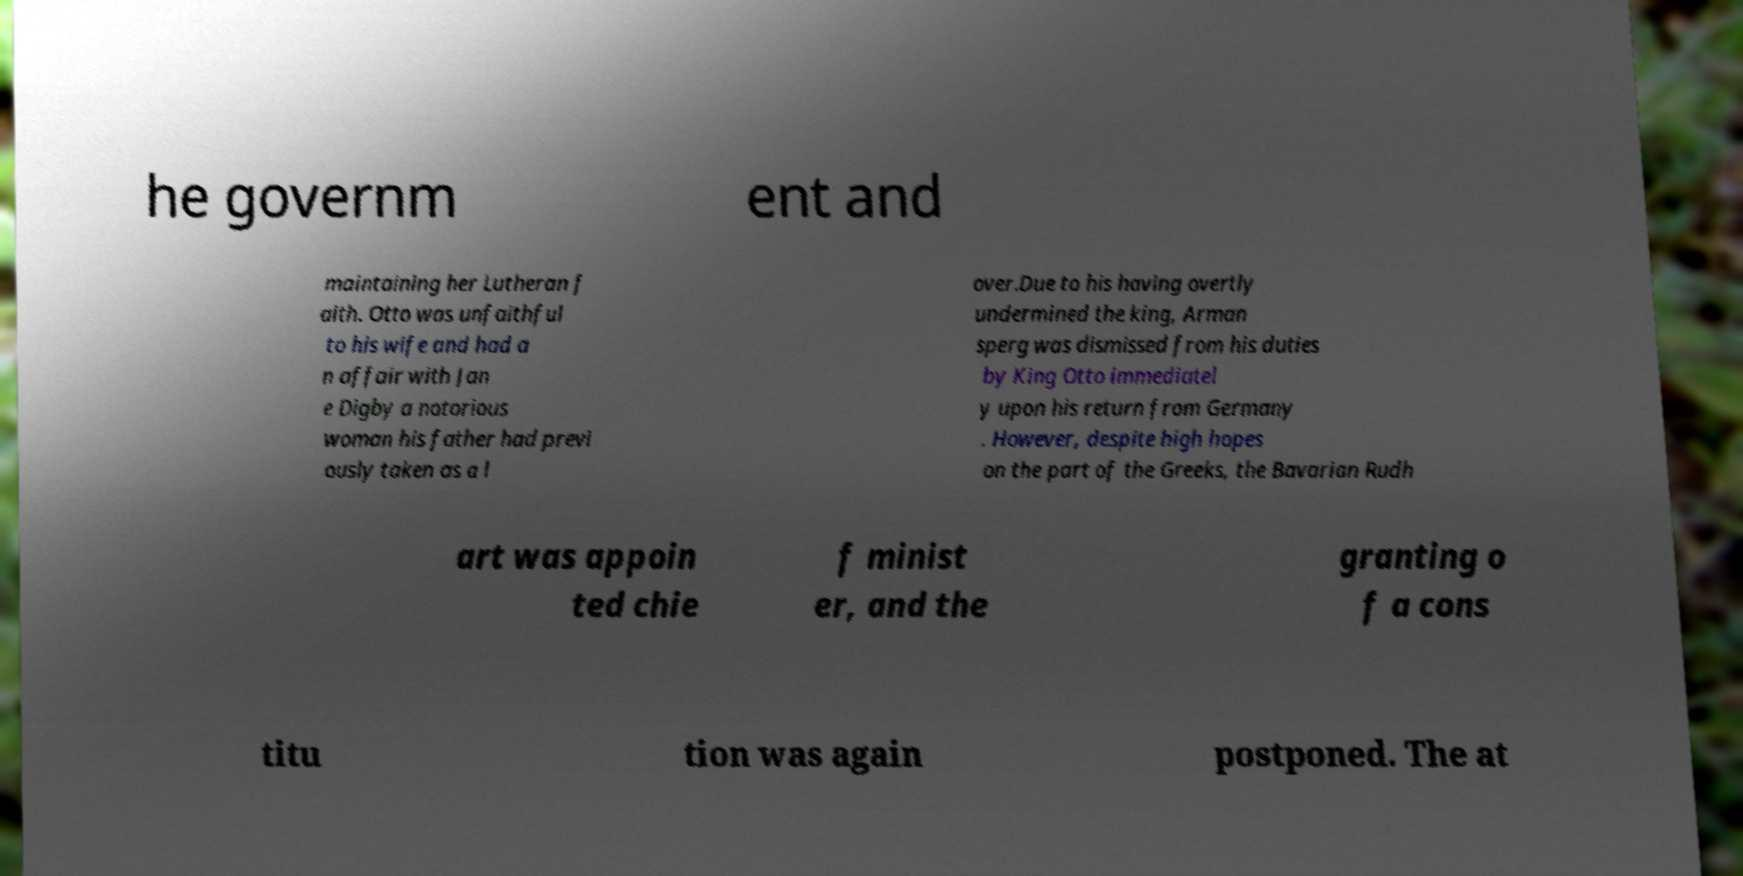For documentation purposes, I need the text within this image transcribed. Could you provide that? he governm ent and maintaining her Lutheran f aith. Otto was unfaithful to his wife and had a n affair with Jan e Digby a notorious woman his father had previ ously taken as a l over.Due to his having overtly undermined the king, Arman sperg was dismissed from his duties by King Otto immediatel y upon his return from Germany . However, despite high hopes on the part of the Greeks, the Bavarian Rudh art was appoin ted chie f minist er, and the granting o f a cons titu tion was again postponed. The at 